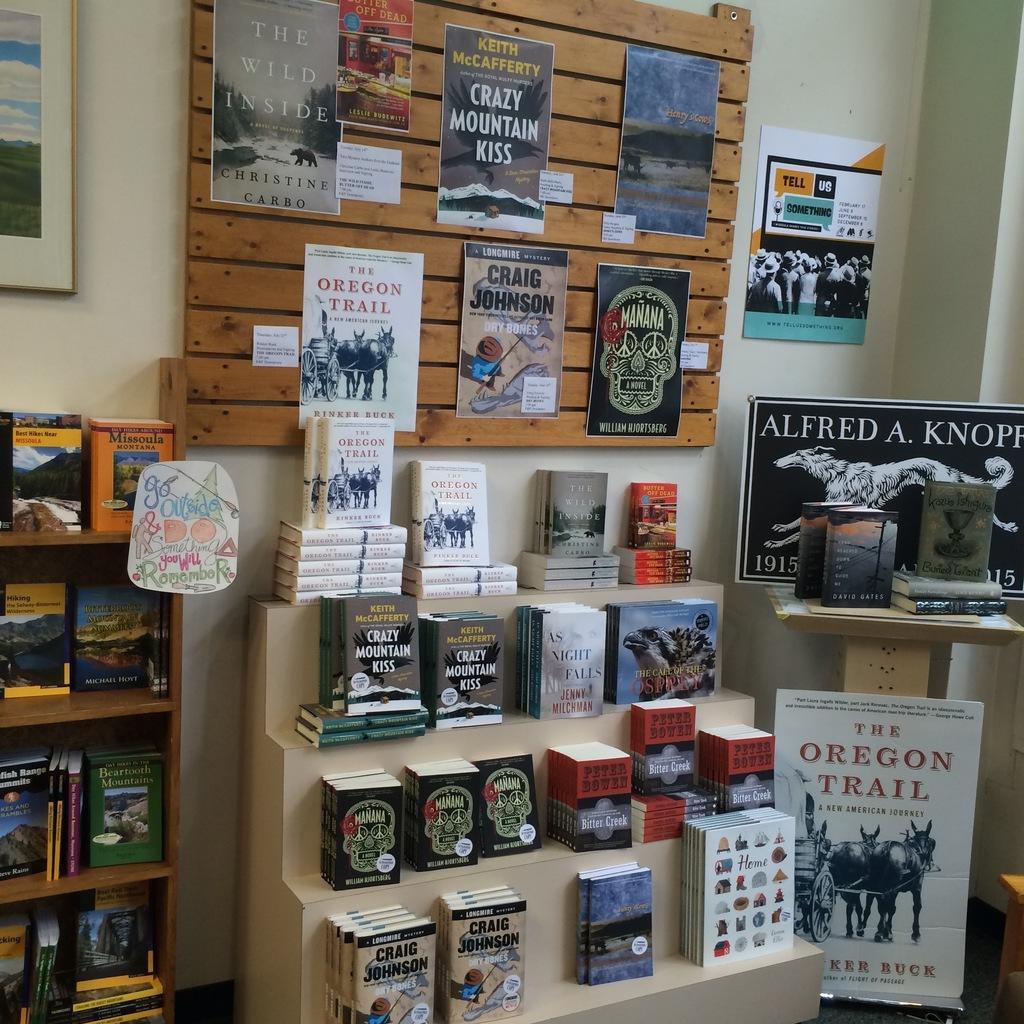Please provide a concise description of this image. In this image, we can see the wall with some objects like posters, wood and a frame. We can see some shelves with objects like books. We can see the ground. We can also see some boards with text and images. We can see an object on the bottom right corner. We can see a table with some books. 